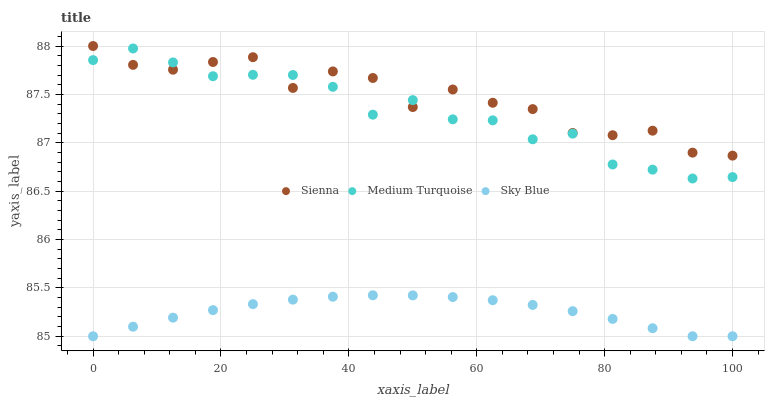Does Sky Blue have the minimum area under the curve?
Answer yes or no. Yes. Does Sienna have the maximum area under the curve?
Answer yes or no. Yes. Does Medium Turquoise have the minimum area under the curve?
Answer yes or no. No. Does Medium Turquoise have the maximum area under the curve?
Answer yes or no. No. Is Sky Blue the smoothest?
Answer yes or no. Yes. Is Sienna the roughest?
Answer yes or no. Yes. Is Medium Turquoise the smoothest?
Answer yes or no. No. Is Medium Turquoise the roughest?
Answer yes or no. No. Does Sky Blue have the lowest value?
Answer yes or no. Yes. Does Medium Turquoise have the lowest value?
Answer yes or no. No. Does Sienna have the highest value?
Answer yes or no. Yes. Does Medium Turquoise have the highest value?
Answer yes or no. No. Is Sky Blue less than Sienna?
Answer yes or no. Yes. Is Medium Turquoise greater than Sky Blue?
Answer yes or no. Yes. Does Medium Turquoise intersect Sienna?
Answer yes or no. Yes. Is Medium Turquoise less than Sienna?
Answer yes or no. No. Is Medium Turquoise greater than Sienna?
Answer yes or no. No. Does Sky Blue intersect Sienna?
Answer yes or no. No. 